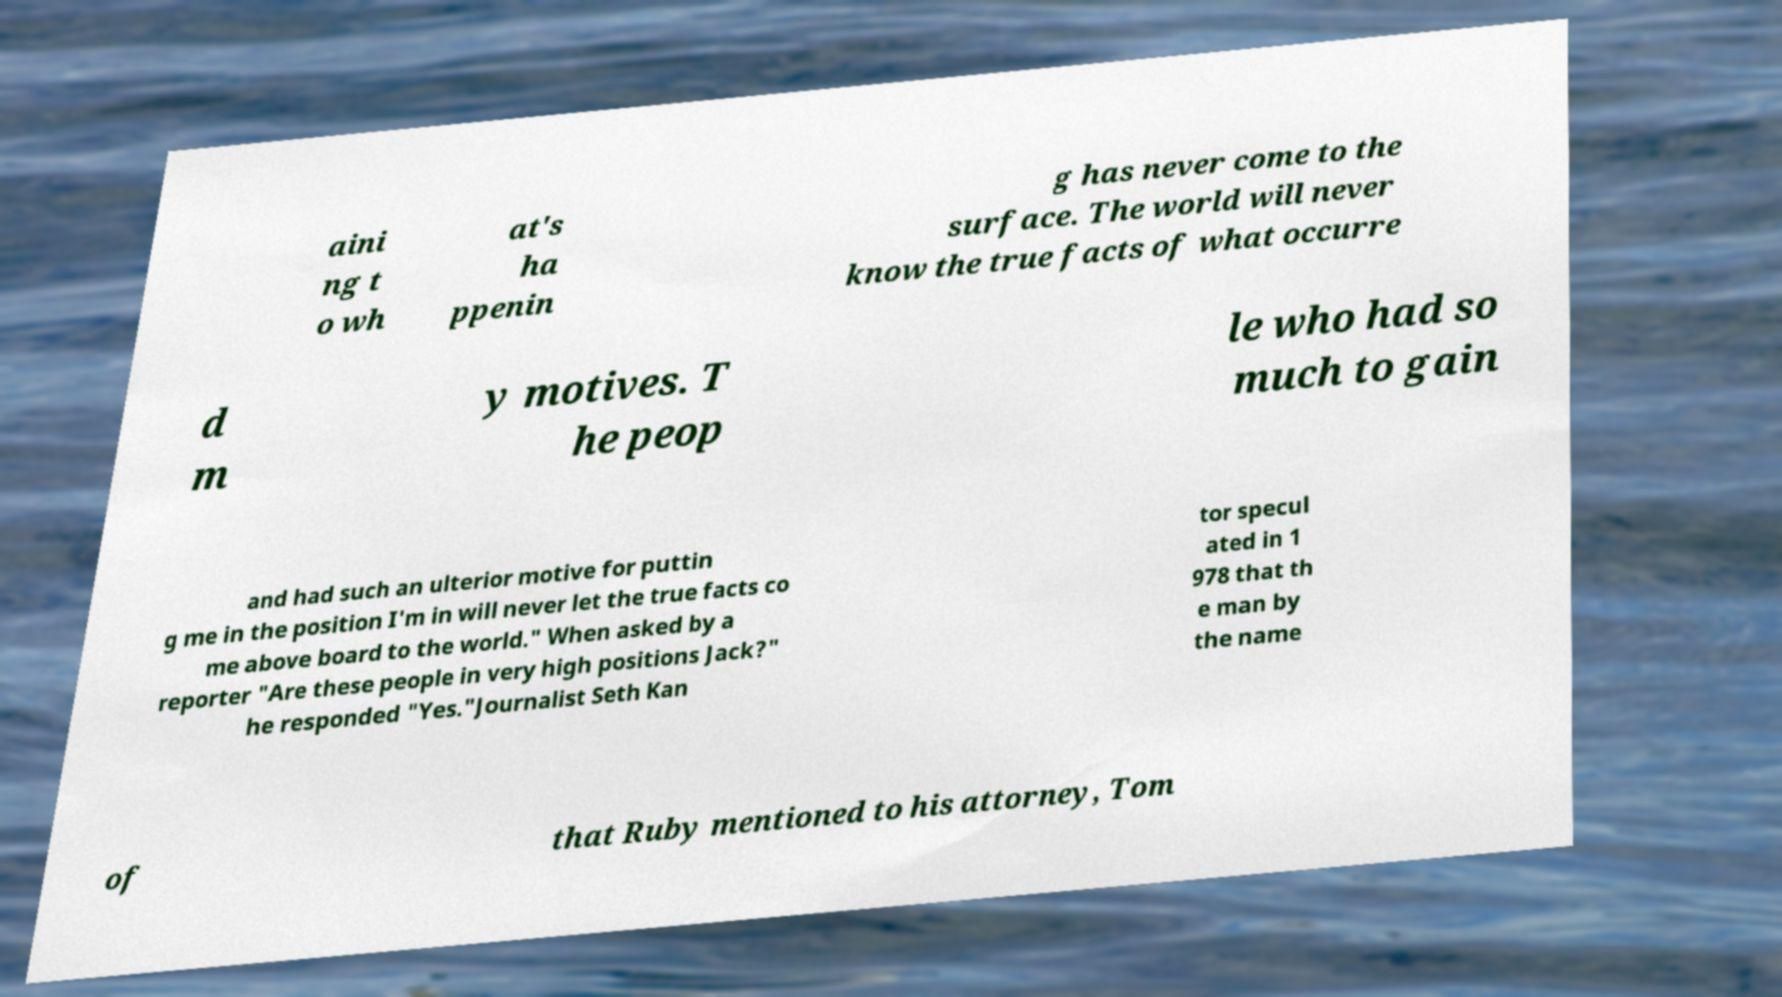Please read and relay the text visible in this image. What does it say? aini ng t o wh at's ha ppenin g has never come to the surface. The world will never know the true facts of what occurre d m y motives. T he peop le who had so much to gain and had such an ulterior motive for puttin g me in the position I'm in will never let the true facts co me above board to the world." When asked by a reporter "Are these people in very high positions Jack?" he responded "Yes."Journalist Seth Kan tor specul ated in 1 978 that th e man by the name of that Ruby mentioned to his attorney, Tom 